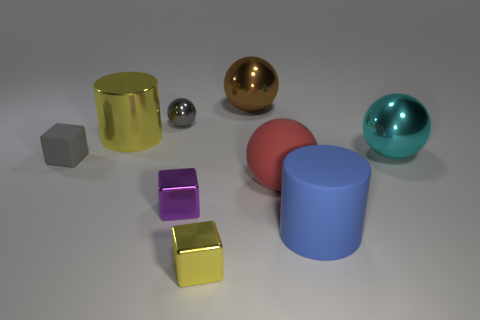Do the gray sphere and the blue cylinder have the same size?
Give a very brief answer. No. What number of things are yellow cubes or big cylinders that are in front of the tiny purple metal object?
Your response must be concise. 2. There is a cyan object that is the same size as the brown metallic sphere; what material is it?
Offer a very short reply. Metal. What is the material of the sphere that is both behind the large metallic cylinder and in front of the big brown sphere?
Ensure brevity in your answer.  Metal. Are there any shiny spheres in front of the cylinder on the right side of the brown metallic object?
Your answer should be very brief. No. What size is the shiny ball that is in front of the brown shiny thing and behind the large cyan object?
Give a very brief answer. Small. What number of green objects are either blocks or big rubber balls?
Provide a succinct answer. 0. The gray shiny thing that is the same size as the purple metal thing is what shape?
Provide a short and direct response. Sphere. What number of other objects are the same color as the large matte sphere?
Offer a terse response. 0. How big is the cylinder to the left of the big ball that is left of the red ball?
Provide a short and direct response. Large. 